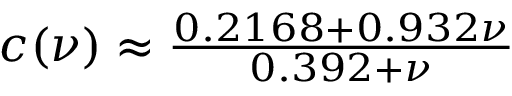<formula> <loc_0><loc_0><loc_500><loc_500>\begin{array} { r } { c ( \nu ) \approx \frac { 0 . 2 1 6 8 + 0 . 9 3 2 \nu } { 0 . 3 9 2 + \nu } } \end{array}</formula> 